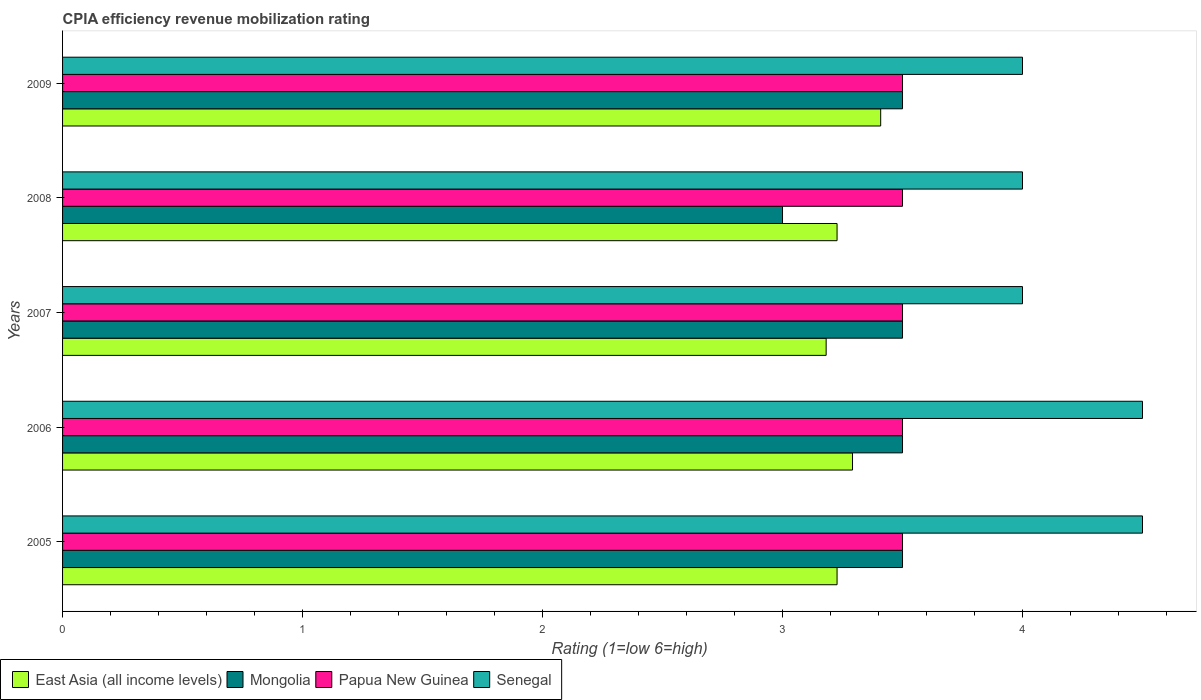How many different coloured bars are there?
Your answer should be very brief. 4. How many groups of bars are there?
Your answer should be very brief. 5. How many bars are there on the 2nd tick from the top?
Keep it short and to the point. 4. What is the CPIA rating in Mongolia in 2006?
Offer a very short reply. 3.5. Across all years, what is the maximum CPIA rating in East Asia (all income levels)?
Your answer should be very brief. 3.41. Across all years, what is the minimum CPIA rating in Mongolia?
Make the answer very short. 3. In which year was the CPIA rating in Papua New Guinea maximum?
Your response must be concise. 2005. What is the total CPIA rating in Senegal in the graph?
Give a very brief answer. 21. What is the difference between the CPIA rating in East Asia (all income levels) in 2005 and that in 2007?
Offer a very short reply. 0.05. What is the difference between the CPIA rating in East Asia (all income levels) in 2005 and the CPIA rating in Mongolia in 2009?
Your answer should be very brief. -0.27. What is the average CPIA rating in East Asia (all income levels) per year?
Offer a terse response. 3.27. In the year 2009, what is the difference between the CPIA rating in East Asia (all income levels) and CPIA rating in Mongolia?
Make the answer very short. -0.09. In how many years, is the CPIA rating in Mongolia greater than 0.2 ?
Your answer should be very brief. 5. What is the ratio of the CPIA rating in Mongolia in 2006 to that in 2008?
Your answer should be compact. 1.17. What is the difference between the highest and the second highest CPIA rating in Senegal?
Your response must be concise. 0. What is the difference between the highest and the lowest CPIA rating in East Asia (all income levels)?
Make the answer very short. 0.23. In how many years, is the CPIA rating in Senegal greater than the average CPIA rating in Senegal taken over all years?
Offer a very short reply. 2. What does the 3rd bar from the top in 2008 represents?
Your answer should be compact. Mongolia. What does the 3rd bar from the bottom in 2007 represents?
Provide a succinct answer. Papua New Guinea. How many years are there in the graph?
Provide a short and direct response. 5. Does the graph contain any zero values?
Your answer should be very brief. No. What is the title of the graph?
Ensure brevity in your answer.  CPIA efficiency revenue mobilization rating. What is the Rating (1=low 6=high) in East Asia (all income levels) in 2005?
Make the answer very short. 3.23. What is the Rating (1=low 6=high) in East Asia (all income levels) in 2006?
Ensure brevity in your answer.  3.29. What is the Rating (1=low 6=high) in Mongolia in 2006?
Keep it short and to the point. 3.5. What is the Rating (1=low 6=high) in Papua New Guinea in 2006?
Your response must be concise. 3.5. What is the Rating (1=low 6=high) in East Asia (all income levels) in 2007?
Offer a very short reply. 3.18. What is the Rating (1=low 6=high) of Senegal in 2007?
Your response must be concise. 4. What is the Rating (1=low 6=high) in East Asia (all income levels) in 2008?
Offer a very short reply. 3.23. What is the Rating (1=low 6=high) in Mongolia in 2008?
Provide a short and direct response. 3. What is the Rating (1=low 6=high) in Papua New Guinea in 2008?
Keep it short and to the point. 3.5. What is the Rating (1=low 6=high) of Senegal in 2008?
Your answer should be compact. 4. What is the Rating (1=low 6=high) of East Asia (all income levels) in 2009?
Make the answer very short. 3.41. What is the Rating (1=low 6=high) in Papua New Guinea in 2009?
Make the answer very short. 3.5. Across all years, what is the maximum Rating (1=low 6=high) of East Asia (all income levels)?
Provide a succinct answer. 3.41. Across all years, what is the maximum Rating (1=low 6=high) in Senegal?
Make the answer very short. 4.5. Across all years, what is the minimum Rating (1=low 6=high) of East Asia (all income levels)?
Offer a terse response. 3.18. Across all years, what is the minimum Rating (1=low 6=high) in Mongolia?
Your answer should be very brief. 3. Across all years, what is the minimum Rating (1=low 6=high) of Papua New Guinea?
Offer a very short reply. 3.5. What is the total Rating (1=low 6=high) of East Asia (all income levels) in the graph?
Offer a terse response. 16.34. What is the total Rating (1=low 6=high) in Mongolia in the graph?
Ensure brevity in your answer.  17. What is the total Rating (1=low 6=high) of Senegal in the graph?
Offer a very short reply. 21. What is the difference between the Rating (1=low 6=high) in East Asia (all income levels) in 2005 and that in 2006?
Make the answer very short. -0.06. What is the difference between the Rating (1=low 6=high) of Papua New Guinea in 2005 and that in 2006?
Your answer should be compact. 0. What is the difference between the Rating (1=low 6=high) of East Asia (all income levels) in 2005 and that in 2007?
Provide a succinct answer. 0.05. What is the difference between the Rating (1=low 6=high) in Mongolia in 2005 and that in 2007?
Your answer should be very brief. 0. What is the difference between the Rating (1=low 6=high) in Senegal in 2005 and that in 2007?
Keep it short and to the point. 0.5. What is the difference between the Rating (1=low 6=high) in East Asia (all income levels) in 2005 and that in 2008?
Your answer should be compact. 0. What is the difference between the Rating (1=low 6=high) in Senegal in 2005 and that in 2008?
Your answer should be compact. 0.5. What is the difference between the Rating (1=low 6=high) in East Asia (all income levels) in 2005 and that in 2009?
Keep it short and to the point. -0.18. What is the difference between the Rating (1=low 6=high) of Papua New Guinea in 2005 and that in 2009?
Your response must be concise. 0. What is the difference between the Rating (1=low 6=high) in Senegal in 2005 and that in 2009?
Ensure brevity in your answer.  0.5. What is the difference between the Rating (1=low 6=high) of East Asia (all income levels) in 2006 and that in 2007?
Offer a very short reply. 0.11. What is the difference between the Rating (1=low 6=high) of Mongolia in 2006 and that in 2007?
Ensure brevity in your answer.  0. What is the difference between the Rating (1=low 6=high) of Papua New Guinea in 2006 and that in 2007?
Offer a terse response. 0. What is the difference between the Rating (1=low 6=high) in Senegal in 2006 and that in 2007?
Your answer should be very brief. 0.5. What is the difference between the Rating (1=low 6=high) of East Asia (all income levels) in 2006 and that in 2008?
Offer a very short reply. 0.06. What is the difference between the Rating (1=low 6=high) in East Asia (all income levels) in 2006 and that in 2009?
Your answer should be very brief. -0.12. What is the difference between the Rating (1=low 6=high) of Papua New Guinea in 2006 and that in 2009?
Give a very brief answer. 0. What is the difference between the Rating (1=low 6=high) of Senegal in 2006 and that in 2009?
Offer a terse response. 0.5. What is the difference between the Rating (1=low 6=high) in East Asia (all income levels) in 2007 and that in 2008?
Offer a very short reply. -0.05. What is the difference between the Rating (1=low 6=high) of Mongolia in 2007 and that in 2008?
Ensure brevity in your answer.  0.5. What is the difference between the Rating (1=low 6=high) in Papua New Guinea in 2007 and that in 2008?
Make the answer very short. 0. What is the difference between the Rating (1=low 6=high) in Senegal in 2007 and that in 2008?
Give a very brief answer. 0. What is the difference between the Rating (1=low 6=high) of East Asia (all income levels) in 2007 and that in 2009?
Make the answer very short. -0.23. What is the difference between the Rating (1=low 6=high) of East Asia (all income levels) in 2008 and that in 2009?
Ensure brevity in your answer.  -0.18. What is the difference between the Rating (1=low 6=high) of Senegal in 2008 and that in 2009?
Your response must be concise. 0. What is the difference between the Rating (1=low 6=high) in East Asia (all income levels) in 2005 and the Rating (1=low 6=high) in Mongolia in 2006?
Make the answer very short. -0.27. What is the difference between the Rating (1=low 6=high) in East Asia (all income levels) in 2005 and the Rating (1=low 6=high) in Papua New Guinea in 2006?
Give a very brief answer. -0.27. What is the difference between the Rating (1=low 6=high) in East Asia (all income levels) in 2005 and the Rating (1=low 6=high) in Senegal in 2006?
Your answer should be compact. -1.27. What is the difference between the Rating (1=low 6=high) in Mongolia in 2005 and the Rating (1=low 6=high) in Papua New Guinea in 2006?
Your response must be concise. 0. What is the difference between the Rating (1=low 6=high) in Mongolia in 2005 and the Rating (1=low 6=high) in Senegal in 2006?
Your answer should be compact. -1. What is the difference between the Rating (1=low 6=high) in Papua New Guinea in 2005 and the Rating (1=low 6=high) in Senegal in 2006?
Provide a short and direct response. -1. What is the difference between the Rating (1=low 6=high) in East Asia (all income levels) in 2005 and the Rating (1=low 6=high) in Mongolia in 2007?
Ensure brevity in your answer.  -0.27. What is the difference between the Rating (1=low 6=high) in East Asia (all income levels) in 2005 and the Rating (1=low 6=high) in Papua New Guinea in 2007?
Your response must be concise. -0.27. What is the difference between the Rating (1=low 6=high) in East Asia (all income levels) in 2005 and the Rating (1=low 6=high) in Senegal in 2007?
Keep it short and to the point. -0.77. What is the difference between the Rating (1=low 6=high) in East Asia (all income levels) in 2005 and the Rating (1=low 6=high) in Mongolia in 2008?
Keep it short and to the point. 0.23. What is the difference between the Rating (1=low 6=high) in East Asia (all income levels) in 2005 and the Rating (1=low 6=high) in Papua New Guinea in 2008?
Provide a short and direct response. -0.27. What is the difference between the Rating (1=low 6=high) in East Asia (all income levels) in 2005 and the Rating (1=low 6=high) in Senegal in 2008?
Ensure brevity in your answer.  -0.77. What is the difference between the Rating (1=low 6=high) in Papua New Guinea in 2005 and the Rating (1=low 6=high) in Senegal in 2008?
Keep it short and to the point. -0.5. What is the difference between the Rating (1=low 6=high) of East Asia (all income levels) in 2005 and the Rating (1=low 6=high) of Mongolia in 2009?
Offer a very short reply. -0.27. What is the difference between the Rating (1=low 6=high) in East Asia (all income levels) in 2005 and the Rating (1=low 6=high) in Papua New Guinea in 2009?
Your answer should be compact. -0.27. What is the difference between the Rating (1=low 6=high) in East Asia (all income levels) in 2005 and the Rating (1=low 6=high) in Senegal in 2009?
Provide a succinct answer. -0.77. What is the difference between the Rating (1=low 6=high) of Mongolia in 2005 and the Rating (1=low 6=high) of Papua New Guinea in 2009?
Provide a succinct answer. 0. What is the difference between the Rating (1=low 6=high) of Mongolia in 2005 and the Rating (1=low 6=high) of Senegal in 2009?
Ensure brevity in your answer.  -0.5. What is the difference between the Rating (1=low 6=high) in Papua New Guinea in 2005 and the Rating (1=low 6=high) in Senegal in 2009?
Keep it short and to the point. -0.5. What is the difference between the Rating (1=low 6=high) of East Asia (all income levels) in 2006 and the Rating (1=low 6=high) of Mongolia in 2007?
Provide a succinct answer. -0.21. What is the difference between the Rating (1=low 6=high) of East Asia (all income levels) in 2006 and the Rating (1=low 6=high) of Papua New Guinea in 2007?
Give a very brief answer. -0.21. What is the difference between the Rating (1=low 6=high) in East Asia (all income levels) in 2006 and the Rating (1=low 6=high) in Senegal in 2007?
Your answer should be compact. -0.71. What is the difference between the Rating (1=low 6=high) of Papua New Guinea in 2006 and the Rating (1=low 6=high) of Senegal in 2007?
Provide a short and direct response. -0.5. What is the difference between the Rating (1=low 6=high) of East Asia (all income levels) in 2006 and the Rating (1=low 6=high) of Mongolia in 2008?
Offer a very short reply. 0.29. What is the difference between the Rating (1=low 6=high) in East Asia (all income levels) in 2006 and the Rating (1=low 6=high) in Papua New Guinea in 2008?
Offer a very short reply. -0.21. What is the difference between the Rating (1=low 6=high) in East Asia (all income levels) in 2006 and the Rating (1=low 6=high) in Senegal in 2008?
Give a very brief answer. -0.71. What is the difference between the Rating (1=low 6=high) of Mongolia in 2006 and the Rating (1=low 6=high) of Papua New Guinea in 2008?
Offer a terse response. 0. What is the difference between the Rating (1=low 6=high) of Papua New Guinea in 2006 and the Rating (1=low 6=high) of Senegal in 2008?
Make the answer very short. -0.5. What is the difference between the Rating (1=low 6=high) of East Asia (all income levels) in 2006 and the Rating (1=low 6=high) of Mongolia in 2009?
Your response must be concise. -0.21. What is the difference between the Rating (1=low 6=high) in East Asia (all income levels) in 2006 and the Rating (1=low 6=high) in Papua New Guinea in 2009?
Provide a short and direct response. -0.21. What is the difference between the Rating (1=low 6=high) of East Asia (all income levels) in 2006 and the Rating (1=low 6=high) of Senegal in 2009?
Offer a terse response. -0.71. What is the difference between the Rating (1=low 6=high) in Mongolia in 2006 and the Rating (1=low 6=high) in Papua New Guinea in 2009?
Keep it short and to the point. 0. What is the difference between the Rating (1=low 6=high) in Mongolia in 2006 and the Rating (1=low 6=high) in Senegal in 2009?
Provide a succinct answer. -0.5. What is the difference between the Rating (1=low 6=high) in East Asia (all income levels) in 2007 and the Rating (1=low 6=high) in Mongolia in 2008?
Ensure brevity in your answer.  0.18. What is the difference between the Rating (1=low 6=high) in East Asia (all income levels) in 2007 and the Rating (1=low 6=high) in Papua New Guinea in 2008?
Provide a succinct answer. -0.32. What is the difference between the Rating (1=low 6=high) in East Asia (all income levels) in 2007 and the Rating (1=low 6=high) in Senegal in 2008?
Keep it short and to the point. -0.82. What is the difference between the Rating (1=low 6=high) of East Asia (all income levels) in 2007 and the Rating (1=low 6=high) of Mongolia in 2009?
Ensure brevity in your answer.  -0.32. What is the difference between the Rating (1=low 6=high) of East Asia (all income levels) in 2007 and the Rating (1=low 6=high) of Papua New Guinea in 2009?
Your response must be concise. -0.32. What is the difference between the Rating (1=low 6=high) in East Asia (all income levels) in 2007 and the Rating (1=low 6=high) in Senegal in 2009?
Keep it short and to the point. -0.82. What is the difference between the Rating (1=low 6=high) in Mongolia in 2007 and the Rating (1=low 6=high) in Senegal in 2009?
Give a very brief answer. -0.5. What is the difference between the Rating (1=low 6=high) of Papua New Guinea in 2007 and the Rating (1=low 6=high) of Senegal in 2009?
Keep it short and to the point. -0.5. What is the difference between the Rating (1=low 6=high) of East Asia (all income levels) in 2008 and the Rating (1=low 6=high) of Mongolia in 2009?
Make the answer very short. -0.27. What is the difference between the Rating (1=low 6=high) of East Asia (all income levels) in 2008 and the Rating (1=low 6=high) of Papua New Guinea in 2009?
Your response must be concise. -0.27. What is the difference between the Rating (1=low 6=high) of East Asia (all income levels) in 2008 and the Rating (1=low 6=high) of Senegal in 2009?
Give a very brief answer. -0.77. What is the difference between the Rating (1=low 6=high) in Mongolia in 2008 and the Rating (1=low 6=high) in Papua New Guinea in 2009?
Provide a short and direct response. -0.5. What is the difference between the Rating (1=low 6=high) in Papua New Guinea in 2008 and the Rating (1=low 6=high) in Senegal in 2009?
Give a very brief answer. -0.5. What is the average Rating (1=low 6=high) of East Asia (all income levels) per year?
Ensure brevity in your answer.  3.27. What is the average Rating (1=low 6=high) in Mongolia per year?
Offer a terse response. 3.4. In the year 2005, what is the difference between the Rating (1=low 6=high) in East Asia (all income levels) and Rating (1=low 6=high) in Mongolia?
Provide a short and direct response. -0.27. In the year 2005, what is the difference between the Rating (1=low 6=high) in East Asia (all income levels) and Rating (1=low 6=high) in Papua New Guinea?
Your answer should be very brief. -0.27. In the year 2005, what is the difference between the Rating (1=low 6=high) of East Asia (all income levels) and Rating (1=low 6=high) of Senegal?
Offer a very short reply. -1.27. In the year 2005, what is the difference between the Rating (1=low 6=high) of Papua New Guinea and Rating (1=low 6=high) of Senegal?
Give a very brief answer. -1. In the year 2006, what is the difference between the Rating (1=low 6=high) of East Asia (all income levels) and Rating (1=low 6=high) of Mongolia?
Provide a succinct answer. -0.21. In the year 2006, what is the difference between the Rating (1=low 6=high) in East Asia (all income levels) and Rating (1=low 6=high) in Papua New Guinea?
Your answer should be very brief. -0.21. In the year 2006, what is the difference between the Rating (1=low 6=high) of East Asia (all income levels) and Rating (1=low 6=high) of Senegal?
Give a very brief answer. -1.21. In the year 2006, what is the difference between the Rating (1=low 6=high) of Mongolia and Rating (1=low 6=high) of Papua New Guinea?
Your response must be concise. 0. In the year 2007, what is the difference between the Rating (1=low 6=high) of East Asia (all income levels) and Rating (1=low 6=high) of Mongolia?
Offer a very short reply. -0.32. In the year 2007, what is the difference between the Rating (1=low 6=high) in East Asia (all income levels) and Rating (1=low 6=high) in Papua New Guinea?
Keep it short and to the point. -0.32. In the year 2007, what is the difference between the Rating (1=low 6=high) in East Asia (all income levels) and Rating (1=low 6=high) in Senegal?
Make the answer very short. -0.82. In the year 2007, what is the difference between the Rating (1=low 6=high) of Mongolia and Rating (1=low 6=high) of Papua New Guinea?
Your answer should be very brief. 0. In the year 2007, what is the difference between the Rating (1=low 6=high) of Mongolia and Rating (1=low 6=high) of Senegal?
Keep it short and to the point. -0.5. In the year 2007, what is the difference between the Rating (1=low 6=high) in Papua New Guinea and Rating (1=low 6=high) in Senegal?
Your answer should be very brief. -0.5. In the year 2008, what is the difference between the Rating (1=low 6=high) of East Asia (all income levels) and Rating (1=low 6=high) of Mongolia?
Provide a short and direct response. 0.23. In the year 2008, what is the difference between the Rating (1=low 6=high) in East Asia (all income levels) and Rating (1=low 6=high) in Papua New Guinea?
Keep it short and to the point. -0.27. In the year 2008, what is the difference between the Rating (1=low 6=high) in East Asia (all income levels) and Rating (1=low 6=high) in Senegal?
Provide a short and direct response. -0.77. In the year 2008, what is the difference between the Rating (1=low 6=high) of Mongolia and Rating (1=low 6=high) of Papua New Guinea?
Ensure brevity in your answer.  -0.5. In the year 2008, what is the difference between the Rating (1=low 6=high) in Papua New Guinea and Rating (1=low 6=high) in Senegal?
Your answer should be very brief. -0.5. In the year 2009, what is the difference between the Rating (1=low 6=high) in East Asia (all income levels) and Rating (1=low 6=high) in Mongolia?
Provide a short and direct response. -0.09. In the year 2009, what is the difference between the Rating (1=low 6=high) of East Asia (all income levels) and Rating (1=low 6=high) of Papua New Guinea?
Ensure brevity in your answer.  -0.09. In the year 2009, what is the difference between the Rating (1=low 6=high) in East Asia (all income levels) and Rating (1=low 6=high) in Senegal?
Offer a terse response. -0.59. In the year 2009, what is the difference between the Rating (1=low 6=high) in Mongolia and Rating (1=low 6=high) in Papua New Guinea?
Your answer should be compact. 0. In the year 2009, what is the difference between the Rating (1=low 6=high) in Mongolia and Rating (1=low 6=high) in Senegal?
Your answer should be compact. -0.5. What is the ratio of the Rating (1=low 6=high) in East Asia (all income levels) in 2005 to that in 2006?
Give a very brief answer. 0.98. What is the ratio of the Rating (1=low 6=high) of Papua New Guinea in 2005 to that in 2006?
Your answer should be compact. 1. What is the ratio of the Rating (1=low 6=high) in East Asia (all income levels) in 2005 to that in 2007?
Provide a succinct answer. 1.01. What is the ratio of the Rating (1=low 6=high) of East Asia (all income levels) in 2005 to that in 2008?
Offer a very short reply. 1. What is the ratio of the Rating (1=low 6=high) of Papua New Guinea in 2005 to that in 2008?
Make the answer very short. 1. What is the ratio of the Rating (1=low 6=high) of East Asia (all income levels) in 2005 to that in 2009?
Provide a short and direct response. 0.95. What is the ratio of the Rating (1=low 6=high) in Mongolia in 2005 to that in 2009?
Your response must be concise. 1. What is the ratio of the Rating (1=low 6=high) in Papua New Guinea in 2005 to that in 2009?
Give a very brief answer. 1. What is the ratio of the Rating (1=low 6=high) of Senegal in 2005 to that in 2009?
Provide a succinct answer. 1.12. What is the ratio of the Rating (1=low 6=high) in East Asia (all income levels) in 2006 to that in 2007?
Offer a terse response. 1.03. What is the ratio of the Rating (1=low 6=high) of Mongolia in 2006 to that in 2007?
Make the answer very short. 1. What is the ratio of the Rating (1=low 6=high) of Papua New Guinea in 2006 to that in 2007?
Offer a very short reply. 1. What is the ratio of the Rating (1=low 6=high) in Senegal in 2006 to that in 2007?
Your answer should be compact. 1.12. What is the ratio of the Rating (1=low 6=high) of East Asia (all income levels) in 2006 to that in 2008?
Give a very brief answer. 1.02. What is the ratio of the Rating (1=low 6=high) in Mongolia in 2006 to that in 2008?
Keep it short and to the point. 1.17. What is the ratio of the Rating (1=low 6=high) of East Asia (all income levels) in 2006 to that in 2009?
Offer a terse response. 0.97. What is the ratio of the Rating (1=low 6=high) of Papua New Guinea in 2006 to that in 2009?
Make the answer very short. 1. What is the ratio of the Rating (1=low 6=high) in East Asia (all income levels) in 2007 to that in 2008?
Offer a terse response. 0.99. What is the ratio of the Rating (1=low 6=high) in Mongolia in 2007 to that in 2008?
Offer a terse response. 1.17. What is the ratio of the Rating (1=low 6=high) in Senegal in 2007 to that in 2008?
Offer a terse response. 1. What is the ratio of the Rating (1=low 6=high) in Senegal in 2007 to that in 2009?
Keep it short and to the point. 1. What is the ratio of the Rating (1=low 6=high) in East Asia (all income levels) in 2008 to that in 2009?
Keep it short and to the point. 0.95. What is the ratio of the Rating (1=low 6=high) of Mongolia in 2008 to that in 2009?
Provide a succinct answer. 0.86. What is the ratio of the Rating (1=low 6=high) of Papua New Guinea in 2008 to that in 2009?
Provide a short and direct response. 1. What is the ratio of the Rating (1=low 6=high) in Senegal in 2008 to that in 2009?
Give a very brief answer. 1. What is the difference between the highest and the second highest Rating (1=low 6=high) of East Asia (all income levels)?
Provide a succinct answer. 0.12. What is the difference between the highest and the second highest Rating (1=low 6=high) of Senegal?
Offer a very short reply. 0. What is the difference between the highest and the lowest Rating (1=low 6=high) of East Asia (all income levels)?
Your response must be concise. 0.23. What is the difference between the highest and the lowest Rating (1=low 6=high) in Senegal?
Your answer should be very brief. 0.5. 